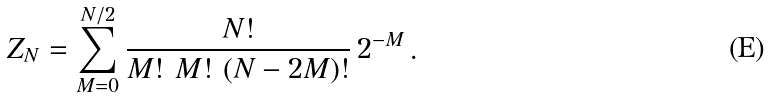<formula> <loc_0><loc_0><loc_500><loc_500>Z _ { N } = \sum _ { M = 0 } ^ { N / 2 } \frac { N ! } { M ! \ M ! \ ( N - 2 M ) ! } \, 2 ^ { - M } \, .</formula> 